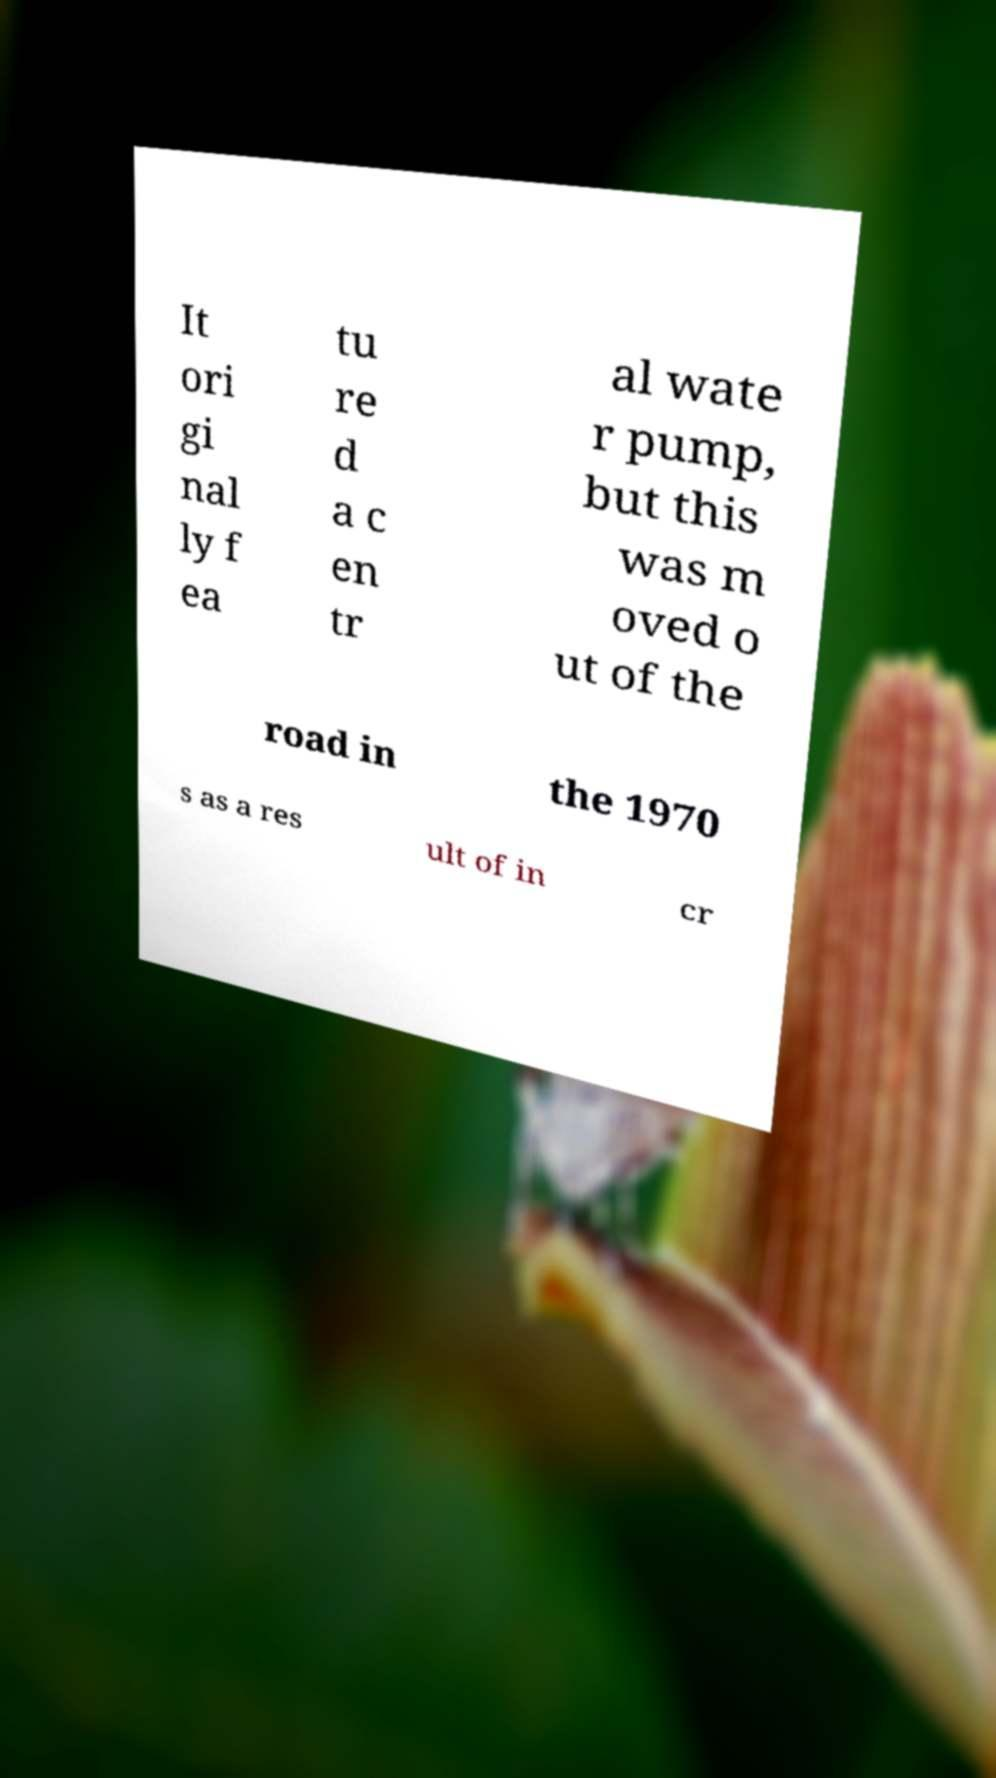What messages or text are displayed in this image? I need them in a readable, typed format. It ori gi nal ly f ea tu re d a c en tr al wate r pump, but this was m oved o ut of the road in the 1970 s as a res ult of in cr 